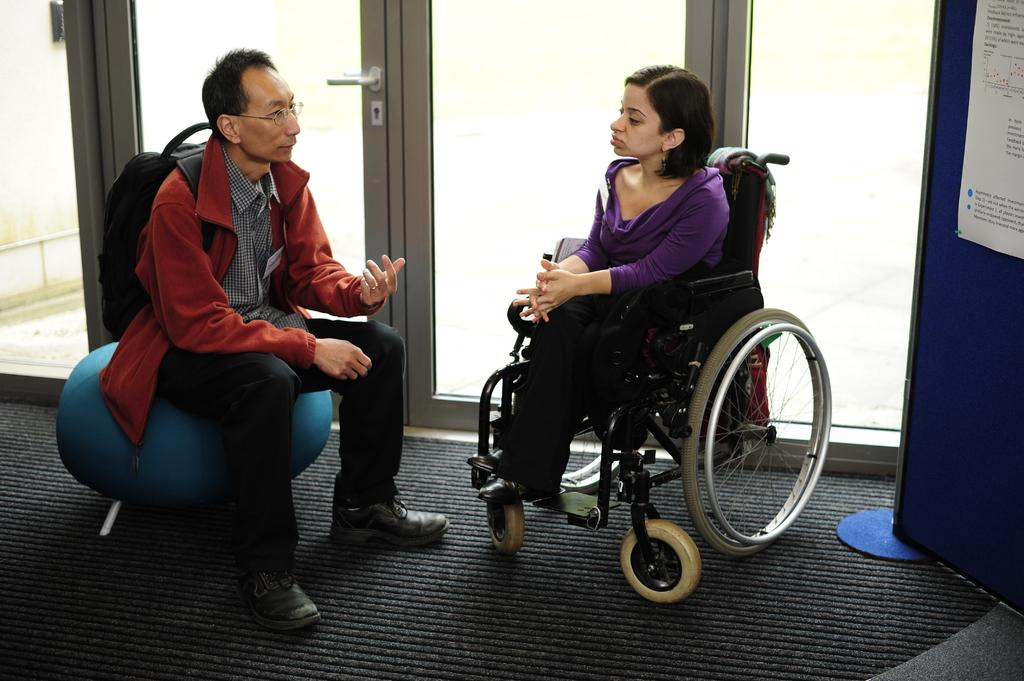What is the man in the image doing? The man is sitting in the image. Who else is present in the image? There is a woman sitting on a wheelchair in the image. What type of doors can be seen in the image? There are glass doors in the image. What is covering the floor in the image? There is a carpet on the floor in the image. What is the topic of the argument between the man and the woman in the image? There is no argument present in the image; both the man and the woman are sitting calmly. 